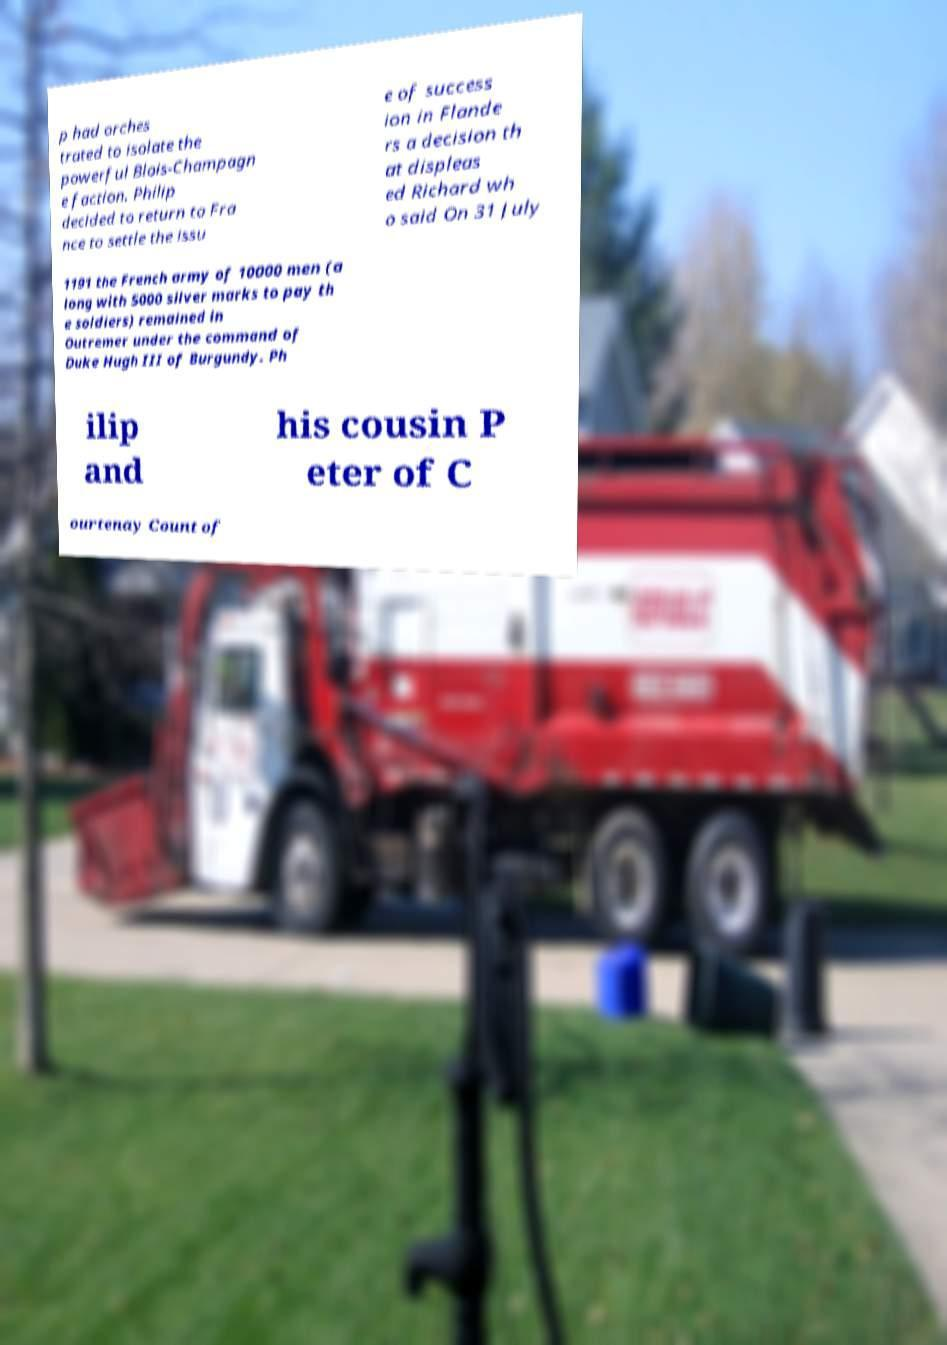Please identify and transcribe the text found in this image. p had orches trated to isolate the powerful Blois-Champagn e faction. Philip decided to return to Fra nce to settle the issu e of success ion in Flande rs a decision th at displeas ed Richard wh o said On 31 July 1191 the French army of 10000 men (a long with 5000 silver marks to pay th e soldiers) remained in Outremer under the command of Duke Hugh III of Burgundy. Ph ilip and his cousin P eter of C ourtenay Count of 